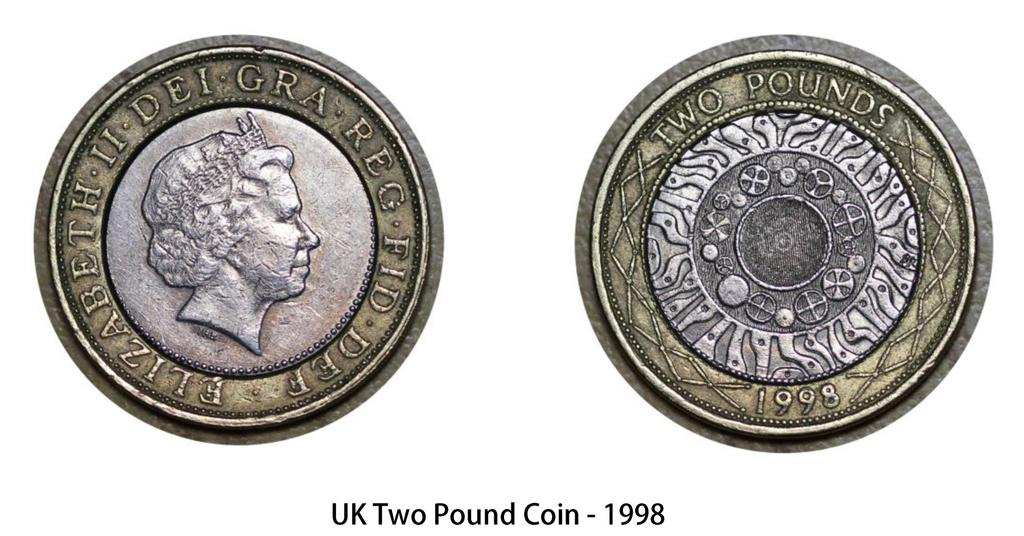What is the main subject of the picture? The main subject of the picture is an image of a coin. What are the two sides of the coin called? The coin has a head side and a tails side. What is written or depicted below the coin? There is text below the coin. What type of hobbies does the coin have in the image? The coin does not have hobbies, as it is an inanimate object. 